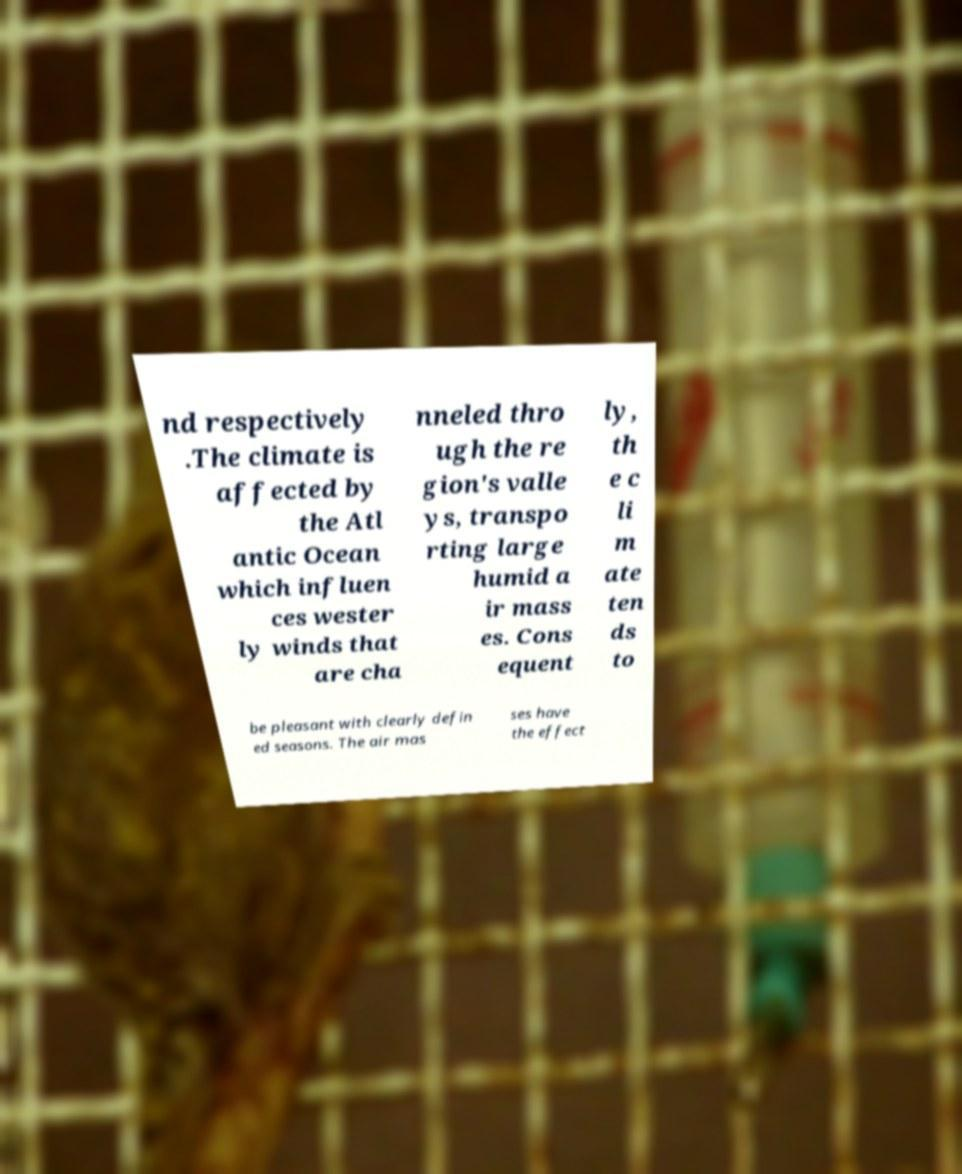Can you read and provide the text displayed in the image?This photo seems to have some interesting text. Can you extract and type it out for me? nd respectively .The climate is affected by the Atl antic Ocean which influen ces wester ly winds that are cha nneled thro ugh the re gion's valle ys, transpo rting large humid a ir mass es. Cons equent ly, th e c li m ate ten ds to be pleasant with clearly defin ed seasons. The air mas ses have the effect 